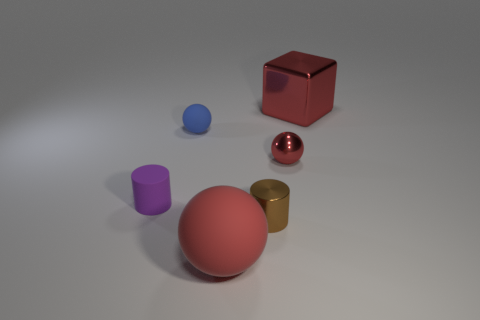Subtract all matte spheres. How many spheres are left? 1 Subtract all red spheres. How many spheres are left? 1 Subtract all cubes. How many objects are left? 5 Subtract 1 spheres. How many spheres are left? 2 Subtract all brown cubes. Subtract all brown balls. How many cubes are left? 1 Subtract all red cubes. How many yellow spheres are left? 0 Subtract all large metal cubes. Subtract all tiny brown metal cylinders. How many objects are left? 4 Add 6 metal spheres. How many metal spheres are left? 7 Add 5 purple things. How many purple things exist? 6 Add 1 purple cylinders. How many objects exist? 7 